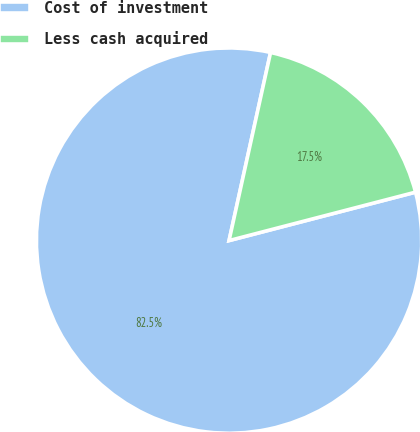Convert chart. <chart><loc_0><loc_0><loc_500><loc_500><pie_chart><fcel>Cost of investment<fcel>Less cash acquired<nl><fcel>82.5%<fcel>17.5%<nl></chart> 